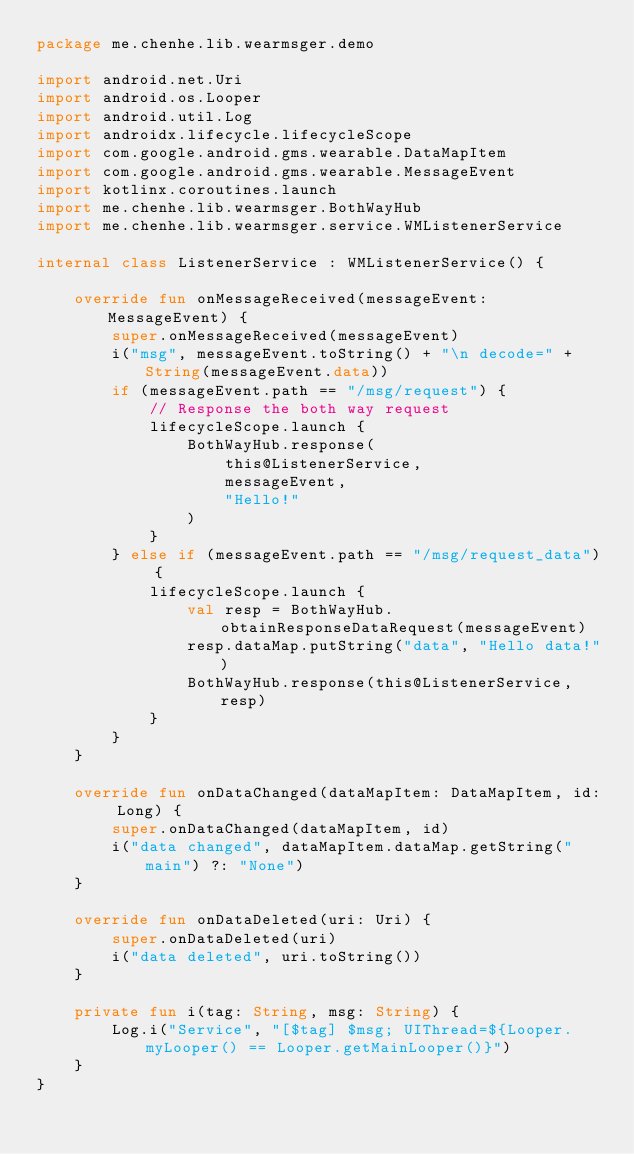Convert code to text. <code><loc_0><loc_0><loc_500><loc_500><_Kotlin_>package me.chenhe.lib.wearmsger.demo

import android.net.Uri
import android.os.Looper
import android.util.Log
import androidx.lifecycle.lifecycleScope
import com.google.android.gms.wearable.DataMapItem
import com.google.android.gms.wearable.MessageEvent
import kotlinx.coroutines.launch
import me.chenhe.lib.wearmsger.BothWayHub
import me.chenhe.lib.wearmsger.service.WMListenerService

internal class ListenerService : WMListenerService() {

    override fun onMessageReceived(messageEvent: MessageEvent) {
        super.onMessageReceived(messageEvent)
        i("msg", messageEvent.toString() + "\n decode=" + String(messageEvent.data))
        if (messageEvent.path == "/msg/request") {
            // Response the both way request
            lifecycleScope.launch {
                BothWayHub.response(
                    this@ListenerService,
                    messageEvent,
                    "Hello!"
                )
            }
        } else if (messageEvent.path == "/msg/request_data") {
            lifecycleScope.launch {
                val resp = BothWayHub.obtainResponseDataRequest(messageEvent)
                resp.dataMap.putString("data", "Hello data!")
                BothWayHub.response(this@ListenerService, resp)
            }
        }
    }

    override fun onDataChanged(dataMapItem: DataMapItem, id: Long) {
        super.onDataChanged(dataMapItem, id)
        i("data changed", dataMapItem.dataMap.getString("main") ?: "None")
    }

    override fun onDataDeleted(uri: Uri) {
        super.onDataDeleted(uri)
        i("data deleted", uri.toString())
    }

    private fun i(tag: String, msg: String) {
        Log.i("Service", "[$tag] $msg; UIThread=${Looper.myLooper() == Looper.getMainLooper()}")
    }
}</code> 